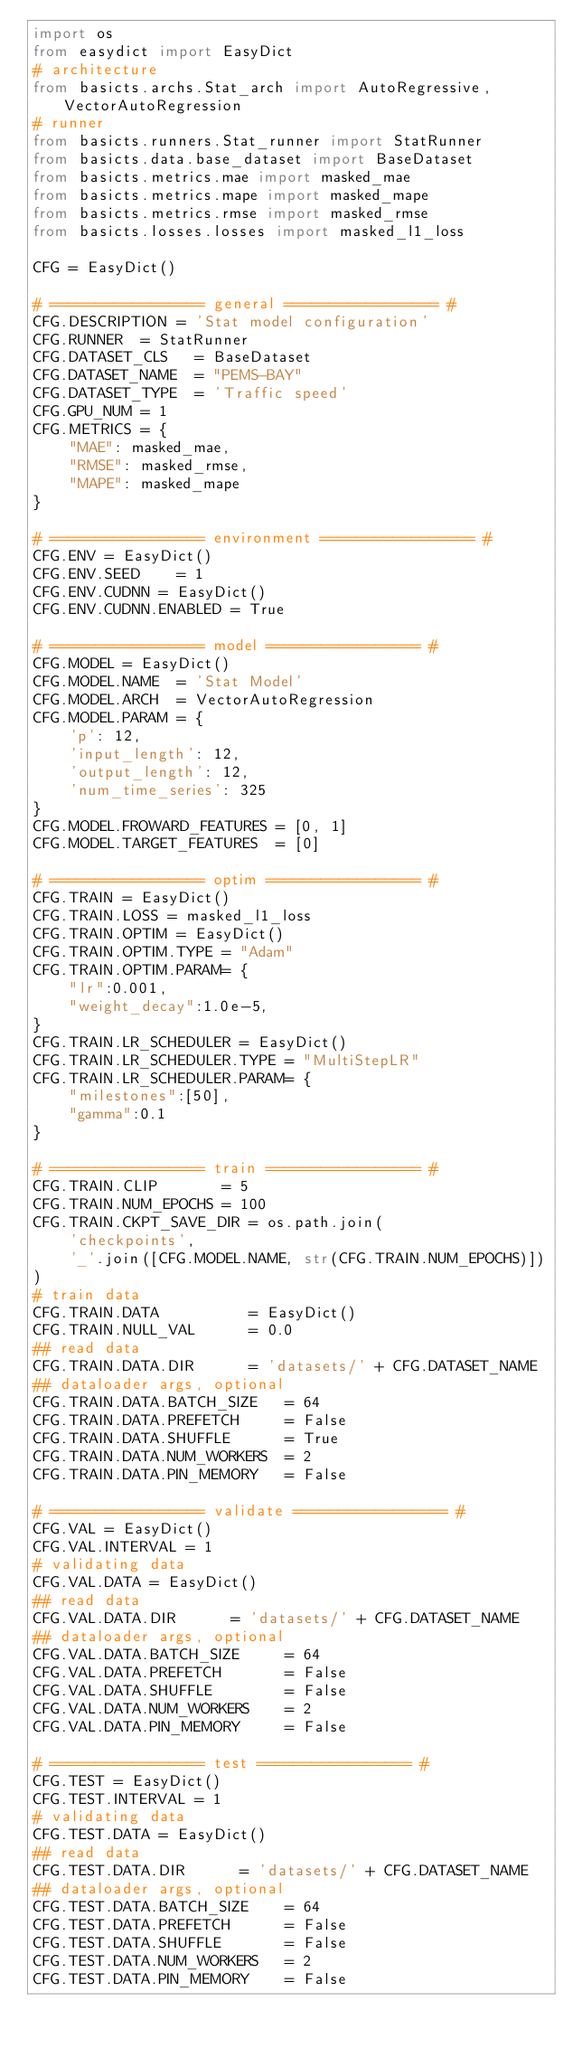<code> <loc_0><loc_0><loc_500><loc_500><_Python_>import os
from easydict import EasyDict
# architecture 
from basicts.archs.Stat_arch import AutoRegressive, VectorAutoRegression
# runner
from basicts.runners.Stat_runner import StatRunner
from basicts.data.base_dataset import BaseDataset
from basicts.metrics.mae import masked_mae
from basicts.metrics.mape import masked_mape
from basicts.metrics.rmse import masked_rmse
from basicts.losses.losses import masked_l1_loss

CFG = EasyDict()

# ================= general ================= #
CFG.DESCRIPTION = 'Stat model configuration'
CFG.RUNNER  = StatRunner
CFG.DATASET_CLS   = BaseDataset
CFG.DATASET_NAME  = "PEMS-BAY"
CFG.DATASET_TYPE  = 'Traffic speed'
CFG.GPU_NUM = 1
CFG.METRICS = {
    "MAE": masked_mae,
    "RMSE": masked_rmse,
    "MAPE": masked_mape
}

# ================= environment ================= #
CFG.ENV = EasyDict()
CFG.ENV.SEED    = 1
CFG.ENV.CUDNN = EasyDict()
CFG.ENV.CUDNN.ENABLED = True

# ================= model ================= #
CFG.MODEL = EasyDict()
CFG.MODEL.NAME  = 'Stat Model'
CFG.MODEL.ARCH  = VectorAutoRegression
CFG.MODEL.PARAM = {
    'p': 12,
    'input_length': 12,
    'output_length': 12,
    'num_time_series': 325
}
CFG.MODEL.FROWARD_FEATURES = [0, 1]            
CFG.MODEL.TARGET_FEATURES  = [0]                

# ================= optim ================= #
CFG.TRAIN = EasyDict()
CFG.TRAIN.LOSS = masked_l1_loss
CFG.TRAIN.OPTIM = EasyDict()
CFG.TRAIN.OPTIM.TYPE = "Adam"
CFG.TRAIN.OPTIM.PARAM= {
    "lr":0.001,
    "weight_decay":1.0e-5,
}
CFG.TRAIN.LR_SCHEDULER = EasyDict()
CFG.TRAIN.LR_SCHEDULER.TYPE = "MultiStepLR"
CFG.TRAIN.LR_SCHEDULER.PARAM= {
    "milestones":[50],
    "gamma":0.1
}

# ================= train ================= #
CFG.TRAIN.CLIP       = 5
CFG.TRAIN.NUM_EPOCHS = 100
CFG.TRAIN.CKPT_SAVE_DIR = os.path.join(
    'checkpoints',
    '_'.join([CFG.MODEL.NAME, str(CFG.TRAIN.NUM_EPOCHS)])
)
# train data
CFG.TRAIN.DATA          = EasyDict()
CFG.TRAIN.NULL_VAL      = 0.0
## read data
CFG.TRAIN.DATA.DIR      = 'datasets/' + CFG.DATASET_NAME
## dataloader args, optional
CFG.TRAIN.DATA.BATCH_SIZE   = 64
CFG.TRAIN.DATA.PREFETCH     = False
CFG.TRAIN.DATA.SHUFFLE      = True
CFG.TRAIN.DATA.NUM_WORKERS  = 2
CFG.TRAIN.DATA.PIN_MEMORY   = False

# ================= validate ================= #
CFG.VAL = EasyDict()
CFG.VAL.INTERVAL = 1
# validating data
CFG.VAL.DATA = EasyDict()
## read data
CFG.VAL.DATA.DIR      = 'datasets/' + CFG.DATASET_NAME
## dataloader args, optional
CFG.VAL.DATA.BATCH_SIZE     = 64
CFG.VAL.DATA.PREFETCH       = False
CFG.VAL.DATA.SHUFFLE        = False
CFG.VAL.DATA.NUM_WORKERS    = 2
CFG.VAL.DATA.PIN_MEMORY     = False

# ================= test ================= #
CFG.TEST = EasyDict()
CFG.TEST.INTERVAL = 1
# validating data
CFG.TEST.DATA = EasyDict()
## read data
CFG.TEST.DATA.DIR      = 'datasets/' + CFG.DATASET_NAME
## dataloader args, optional
CFG.TEST.DATA.BATCH_SIZE    = 64
CFG.TEST.DATA.PREFETCH      = False
CFG.TEST.DATA.SHUFFLE       = False
CFG.TEST.DATA.NUM_WORKERS   = 2
CFG.TEST.DATA.PIN_MEMORY    = False
</code> 